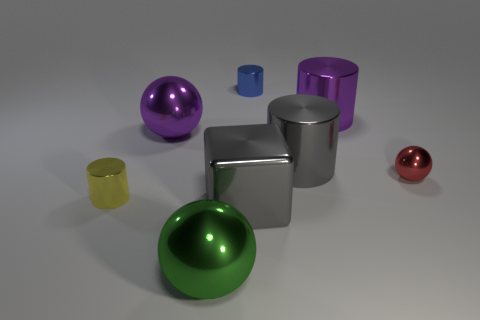What color is the other tiny object that is the same shape as the blue thing?
Offer a terse response. Yellow. Are the big purple cylinder and the small cylinder left of the green metal object made of the same material?
Ensure brevity in your answer.  Yes. There is a big purple object that is to the right of the metal sphere in front of the small metal sphere; what shape is it?
Your response must be concise. Cylinder. There is a ball right of the blue metal cylinder; is its size the same as the tiny blue cylinder?
Give a very brief answer. Yes. What number of other objects are the same shape as the tiny yellow shiny object?
Your response must be concise. 3. There is a large object that is right of the gray cylinder; does it have the same color as the block?
Your answer should be compact. No. Is there a large shiny cube of the same color as the small sphere?
Your answer should be compact. No. There is a small blue metal cylinder; how many shiny things are in front of it?
Give a very brief answer. 7. How many other objects are there of the same size as the gray metallic cube?
Keep it short and to the point. 4. Is the gray object in front of the small metal ball made of the same material as the sphere to the right of the tiny blue shiny cylinder?
Your answer should be compact. Yes. 